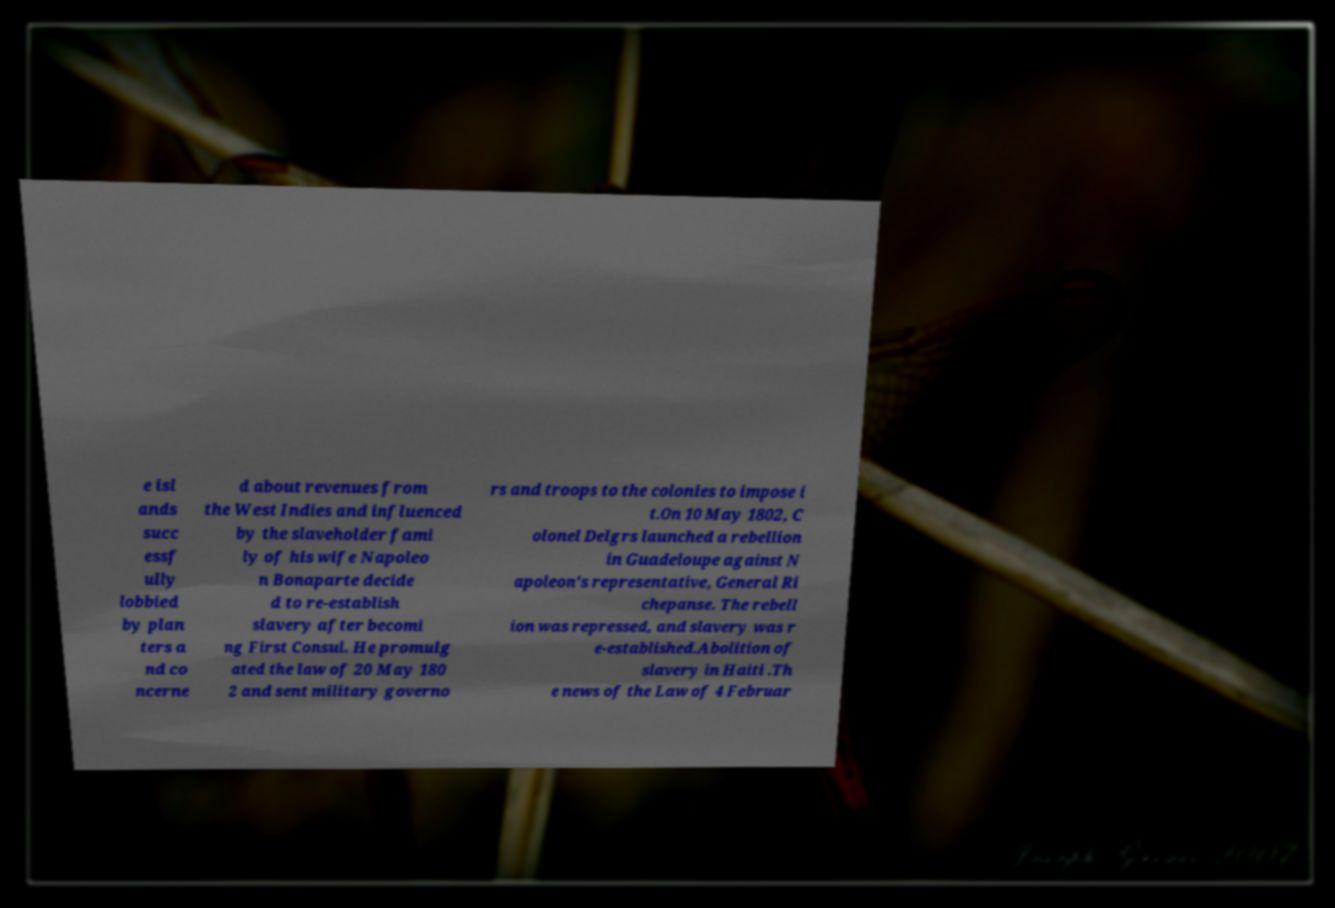Can you accurately transcribe the text from the provided image for me? e isl ands succ essf ully lobbied by plan ters a nd co ncerne d about revenues from the West Indies and influenced by the slaveholder fami ly of his wife Napoleo n Bonaparte decide d to re-establish slavery after becomi ng First Consul. He promulg ated the law of 20 May 180 2 and sent military governo rs and troops to the colonies to impose i t.On 10 May 1802, C olonel Delgrs launched a rebellion in Guadeloupe against N apoleon's representative, General Ri chepanse. The rebell ion was repressed, and slavery was r e-established.Abolition of slavery in Haiti .Th e news of the Law of 4 Februar 